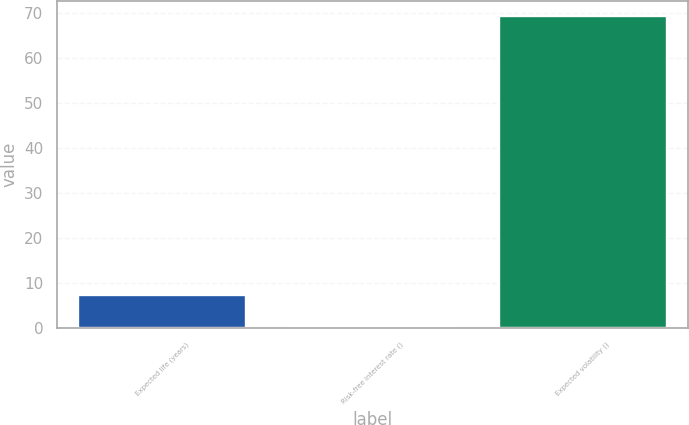Convert chart to OTSL. <chart><loc_0><loc_0><loc_500><loc_500><bar_chart><fcel>Expected life (years)<fcel>Risk-free interest rate ()<fcel>Expected volatility ()<nl><fcel>7.28<fcel>0.4<fcel>69.2<nl></chart> 